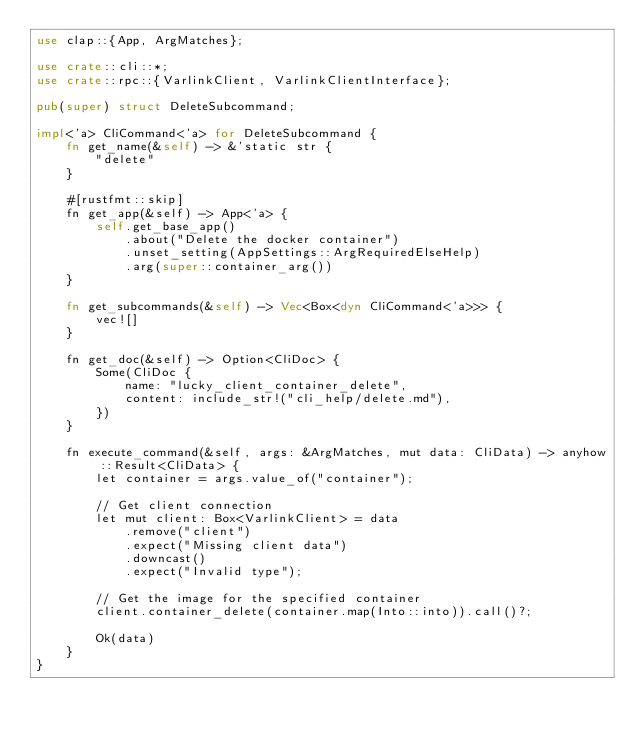Convert code to text. <code><loc_0><loc_0><loc_500><loc_500><_Rust_>use clap::{App, ArgMatches};

use crate::cli::*;
use crate::rpc::{VarlinkClient, VarlinkClientInterface};

pub(super) struct DeleteSubcommand;

impl<'a> CliCommand<'a> for DeleteSubcommand {
    fn get_name(&self) -> &'static str {
        "delete"
    }

    #[rustfmt::skip]
    fn get_app(&self) -> App<'a> {
        self.get_base_app()
            .about("Delete the docker container")
            .unset_setting(AppSettings::ArgRequiredElseHelp)
            .arg(super::container_arg())
    }

    fn get_subcommands(&self) -> Vec<Box<dyn CliCommand<'a>>> {
        vec![]
    }

    fn get_doc(&self) -> Option<CliDoc> {
        Some(CliDoc {
            name: "lucky_client_container_delete",
            content: include_str!("cli_help/delete.md"),
        })
    }

    fn execute_command(&self, args: &ArgMatches, mut data: CliData) -> anyhow::Result<CliData> {
        let container = args.value_of("container");

        // Get client connection
        let mut client: Box<VarlinkClient> = data
            .remove("client")
            .expect("Missing client data")
            .downcast()
            .expect("Invalid type");

        // Get the image for the specified container
        client.container_delete(container.map(Into::into)).call()?;

        Ok(data)
    }
}
</code> 